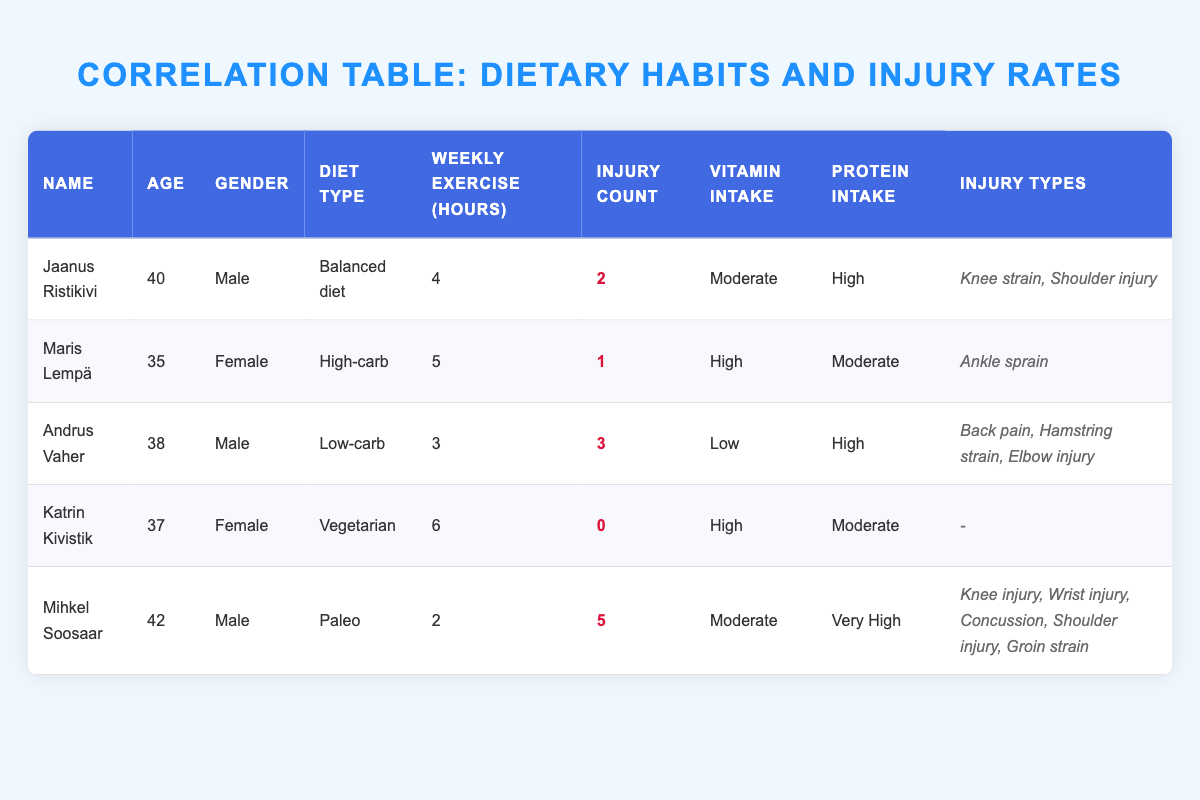What is the diet type of Jaanus Ristikivi? Jaanus Ristikivi is listed under the “Diet Type” column of the table, where it shows "Balanced diet" next to his name.
Answer: Balanced diet How many injury types did Mihkel Soosaar have? The "Injury Types" column shows that Mihkel Soosaar had five different injuries: Knee injury, Wrist injury, Concussion, Shoulder injury, and Groin strain.
Answer: 5 Who has the highest injury count among the athletes? By looking at the "Injury Count" column, Mihkel Soosaar has the highest count listed as 5.
Answer: Mihkel Soosaar What is the average weekly exercise hours of the athletes? To find the average, add the weekly exercise hours: (4 + 5 + 3 + 6 + 2) = 20, and divide by the number of athletes (5), which gives 20/5 = 4.
Answer: 4 Is Katrin Kivistik a vegetarian? The "Diet Type" column indicates that Katrin Kivistik's diet type is "Vegetarian." Thus, the statement is true.
Answer: Yes Which athlete has the lowest vitamin intake? The athlete with the lowest vitamin intake is Andrus Vaher, who has "Low" vitamin intake according to the "Vitamin Intake" column.
Answer: Andrus Vaher How many females had an injury count of 1 or less? The female athletes are Maris Lempä and Katrin Kivistik. Maris had 1 injury and Katrin had 0, totaling 2 females with 1 or less.
Answer: 2 What is the correlation between high protein intake and injury count? Analyzing the "Protein Intake" column, Andrus Vaher (High, 3 injuries), Jaanus Ristikivi (High, 2 injuries), and Mihkel Soosaar (Very High, 5 injuries) all show high or very high protein intake with higher injury counts. This suggests a positive correlation between them.
Answer: Positive correlation How many athletes exercised more than 4 hours a week? Examining the "Weekly Exercise" column, Jaanus Ristikivi (4), Maris Lempä (5), and Katrin Kivistik (6) are the athletes who exercised more than 4 hours, which counts to 2 athletes.
Answer: 2 